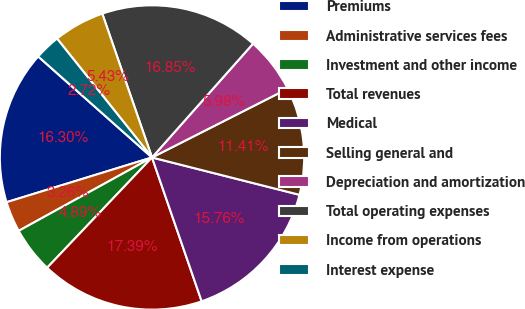<chart> <loc_0><loc_0><loc_500><loc_500><pie_chart><fcel>Premiums<fcel>Administrative services fees<fcel>Investment and other income<fcel>Total revenues<fcel>Medical<fcel>Selling general and<fcel>Depreciation and amortization<fcel>Total operating expenses<fcel>Income from operations<fcel>Interest expense<nl><fcel>16.3%<fcel>3.26%<fcel>4.89%<fcel>17.39%<fcel>15.76%<fcel>11.41%<fcel>5.98%<fcel>16.85%<fcel>5.43%<fcel>2.72%<nl></chart> 